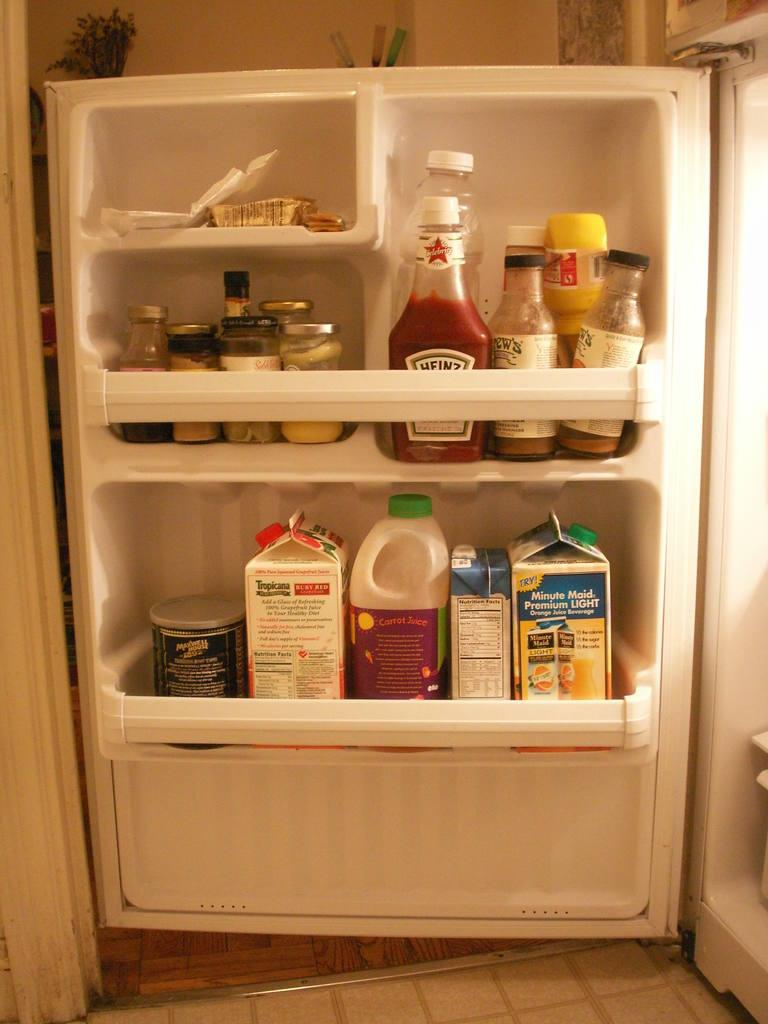<image>
Create a compact narrative representing the image presented. Heinz ketchup in a fridge next to some other bottles. 